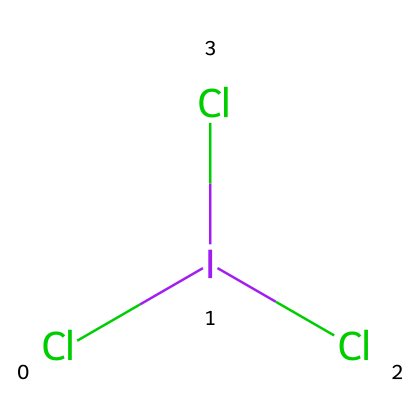What is the chemical name of the compound? The compound represented by the SMILES notation Cl[I](Cl)Cl is iodine trichloride, which indicates it consists of one iodine atom and three chlorine atoms.
Answer: iodine trichloride How many chlorine atoms are in the chemical structure? From the SMILES representation, we can count three chlorine atoms indicated by Cl before the brackets and one chlorine in the brackets, making a total of three chlorine atoms.
Answer: three What is the central atom in this hypervalent compound? The structure reveals that iodine is at the center of the molecule, as it is surrounded by the chlorine atoms, which confirms its role as the central atom.
Answer: iodine What type of bonding is present in iodine trichloride? The presence of three chlorine atoms bonded to a single iodine atom via covalent bonds indicates that the bonding in this molecule is covalent in nature.
Answer: covalent How many total valence electrons are around the iodine atom? Iodine typically has seven valence electrons and each chlorine contributes one from the three bonds made with iodine; therefore, iodine in this configuration has ten valence electrons (7 from iodine plus 3 from the three chlorine bonds).
Answer: ten Is iodine trichloride considered a hypervalent compound? Yes, iodine trichloride has more bonds (three) than would normally be allowed by the octet rule for iodine, which confirms it fits the definition of a hypervalent compound.
Answer: yes 